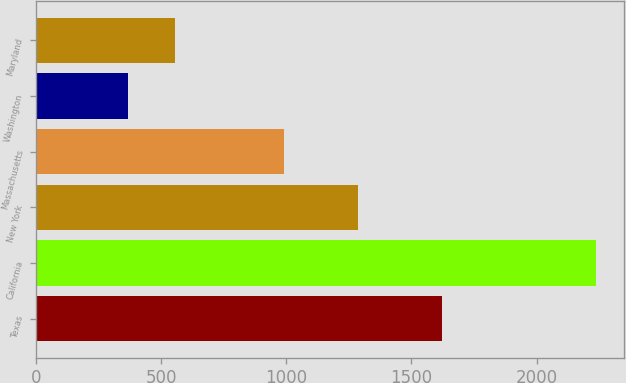Convert chart. <chart><loc_0><loc_0><loc_500><loc_500><bar_chart><fcel>Texas<fcel>California<fcel>New York<fcel>Massachusetts<fcel>Washington<fcel>Maryland<nl><fcel>1622<fcel>2237<fcel>1288<fcel>991<fcel>366<fcel>553.1<nl></chart> 